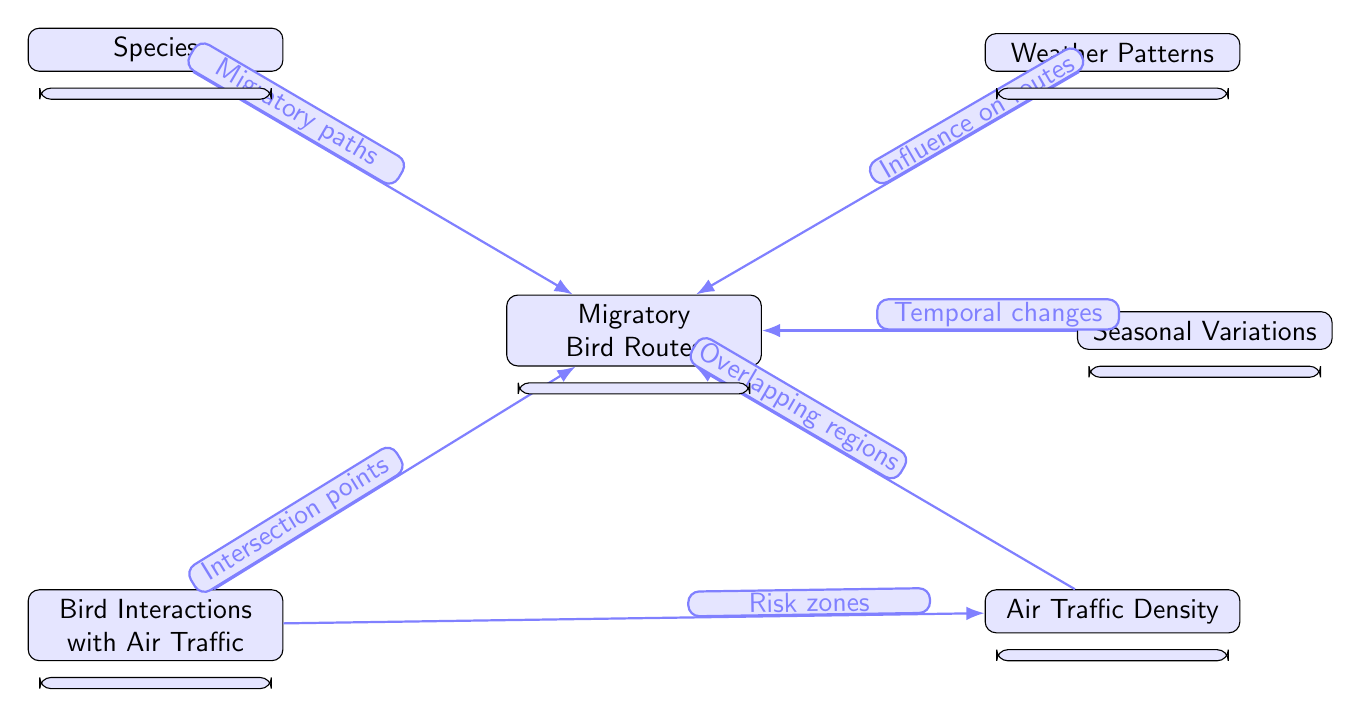What are the main components of the diagram? The diagram consists of six main components: Migratory Bird Routes, Species, Bird Interactions with Air Traffic, Weather Patterns, Seasonal Variations, and Air Traffic Density. Each component plays a role in understanding migratory patterns and air traffic overlaps.
Answer: Migratory Bird Routes, Species, Bird Interactions with Air Traffic, Weather Patterns, Seasonal Variations, Air Traffic Density How many nodes are present in the diagram? The diagram contains a total of six nodes: migratory bird routes, species, bird interactions with air traffic, weather patterns, seasonal variations, and air traffic density. Each node represents a distinct aspect of the study.
Answer: Six What type of relationship exists between "Weather Patterns" and "Migratory Bird Routes"? The relationship indicates that weather patterns have an influence on the migratory bird routes, suggesting that environmental factors can affect the paths taken by birds during migration.
Answer: Influence on routes How do "Bird Interactions with Air Traffic" relate to "Air Traffic Density"? The relationship suggests that there are risk zones identified where bird interactions with air traffic are more likely to occur, indicating an overlap or problematic intersection between migration and busy air traffic areas.
Answer: Risk zones What is the significance of "Seasonal Variations" in the context of the diagram? Seasonal variations are presented as a component that leads to temporal changes in migratory paths, which illustrates how the changing seasons alter the migration behaviors and routes of birds.
Answer: Temporal changes How many edges are connected to the "Migratory Bird Routes" node? There are five edges connected to the "Migratory Bird Routes" node, each one representing a link to another factor involving migratory patterns, indicating the complexity and interrelatedness of the factors at play.
Answer: Five What does "Air Traffic Density" signify about bird migration risk? "Air Traffic Density" indicates overlapping regions with bird migration patterns, which highlights areas where the likelihood of bird collisions with aircraft is increased, necessitating awareness in air traffic management.
Answer: Overlapping regions What does the arrow from "Species" to "Migratory Bird Routes" indicate? The arrow signifies that specific species have defined migratory paths, reinforcing that individual characteristics of different bird species dictate their routes during migration.
Answer: Migratory paths What kind of data does this natural science diagram primarily analyze? The diagram primarily analyzes data related to migratory bird patterns and their interactions with air traffic routes, illustrating the ecological and safety considerations necessary for both wildlife and aviation.
Answer: Migratory bird patterns and air traffic routes 